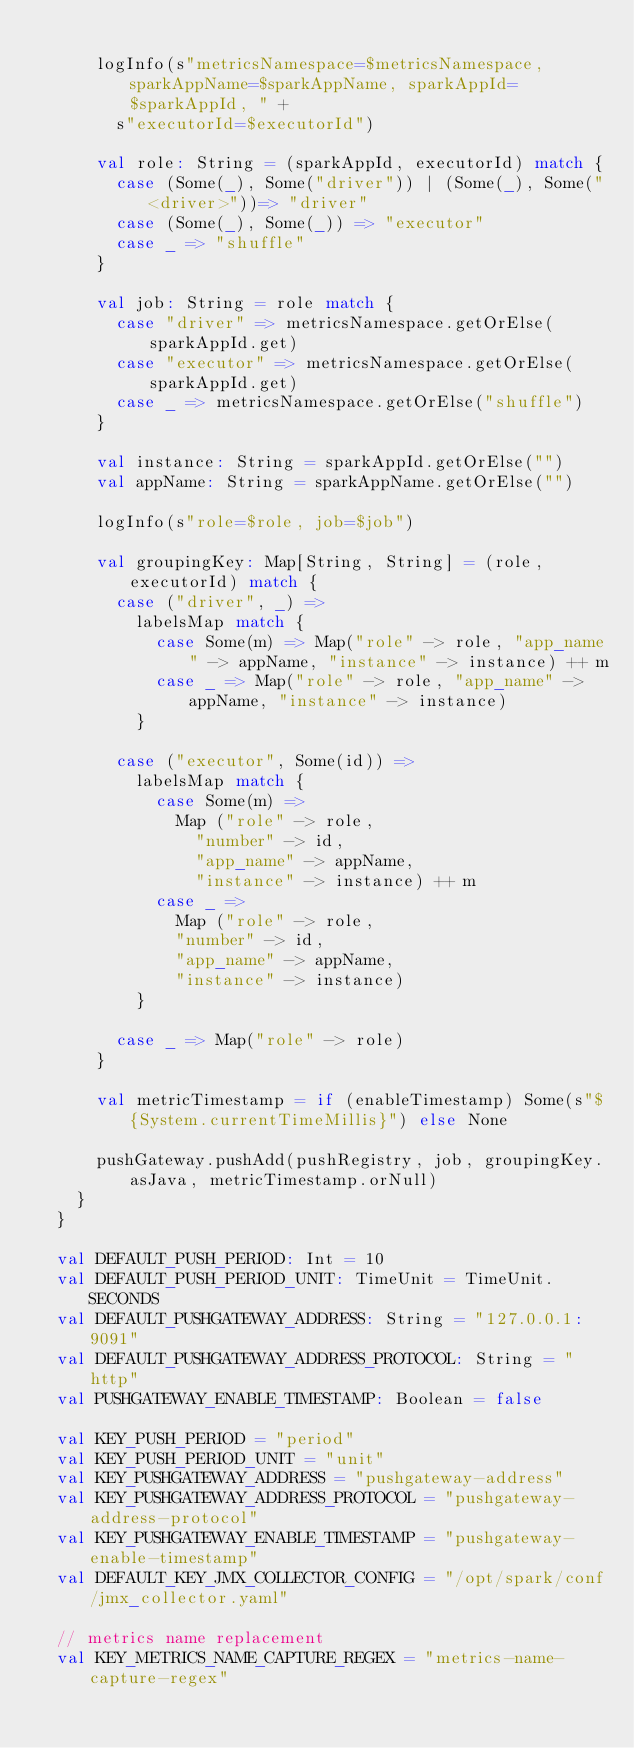<code> <loc_0><loc_0><loc_500><loc_500><_Scala_>
      logInfo(s"metricsNamespace=$metricsNamespace, sparkAppName=$sparkAppName, sparkAppId=$sparkAppId, " +
        s"executorId=$executorId")

      val role: String = (sparkAppId, executorId) match {
        case (Some(_), Some("driver")) | (Some(_), Some("<driver>"))=> "driver"
        case (Some(_), Some(_)) => "executor"
        case _ => "shuffle"
      }

      val job: String = role match {
        case "driver" => metricsNamespace.getOrElse(sparkAppId.get)
        case "executor" => metricsNamespace.getOrElse(sparkAppId.get)
        case _ => metricsNamespace.getOrElse("shuffle")
      }

      val instance: String = sparkAppId.getOrElse("")
      val appName: String = sparkAppName.getOrElse("")

      logInfo(s"role=$role, job=$job")

      val groupingKey: Map[String, String] = (role, executorId) match {
        case ("driver", _) =>
          labelsMap match {
            case Some(m) => Map("role" -> role, "app_name" -> appName, "instance" -> instance) ++ m
            case _ => Map("role" -> role, "app_name" -> appName, "instance" -> instance)
          }

        case ("executor", Some(id)) =>
          labelsMap match {
            case Some(m) =>
              Map ("role" -> role,
                "number" -> id,
                "app_name" -> appName,
                "instance" -> instance) ++ m
            case _ =>
              Map ("role" -> role,
              "number" -> id,
              "app_name" -> appName,
              "instance" -> instance)
          }

        case _ => Map("role" -> role)
      }

      val metricTimestamp = if (enableTimestamp) Some(s"${System.currentTimeMillis}") else None

      pushGateway.pushAdd(pushRegistry, job, groupingKey.asJava, metricTimestamp.orNull)
    }
  }

  val DEFAULT_PUSH_PERIOD: Int = 10
  val DEFAULT_PUSH_PERIOD_UNIT: TimeUnit = TimeUnit.SECONDS
  val DEFAULT_PUSHGATEWAY_ADDRESS: String = "127.0.0.1:9091"
  val DEFAULT_PUSHGATEWAY_ADDRESS_PROTOCOL: String = "http"
  val PUSHGATEWAY_ENABLE_TIMESTAMP: Boolean = false

  val KEY_PUSH_PERIOD = "period"
  val KEY_PUSH_PERIOD_UNIT = "unit"
  val KEY_PUSHGATEWAY_ADDRESS = "pushgateway-address"
  val KEY_PUSHGATEWAY_ADDRESS_PROTOCOL = "pushgateway-address-protocol"
  val KEY_PUSHGATEWAY_ENABLE_TIMESTAMP = "pushgateway-enable-timestamp"
  val DEFAULT_KEY_JMX_COLLECTOR_CONFIG = "/opt/spark/conf/jmx_collector.yaml"

  // metrics name replacement
  val KEY_METRICS_NAME_CAPTURE_REGEX = "metrics-name-capture-regex"</code> 